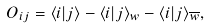<formula> <loc_0><loc_0><loc_500><loc_500>O _ { i j } = \langle i | j \rangle - \langle i | j \rangle _ { w } - \langle i | j \rangle _ { \overline { w } } ,</formula> 